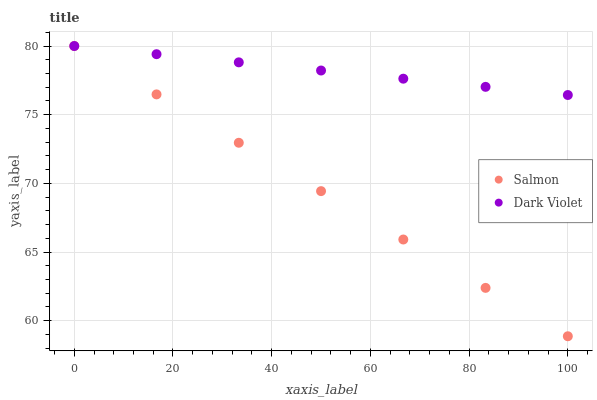Does Salmon have the minimum area under the curve?
Answer yes or no. Yes. Does Dark Violet have the maximum area under the curve?
Answer yes or no. Yes. Does Dark Violet have the minimum area under the curve?
Answer yes or no. No. Is Salmon the smoothest?
Answer yes or no. Yes. Is Dark Violet the roughest?
Answer yes or no. Yes. Is Dark Violet the smoothest?
Answer yes or no. No. Does Salmon have the lowest value?
Answer yes or no. Yes. Does Dark Violet have the lowest value?
Answer yes or no. No. Does Dark Violet have the highest value?
Answer yes or no. Yes. Does Dark Violet intersect Salmon?
Answer yes or no. Yes. Is Dark Violet less than Salmon?
Answer yes or no. No. Is Dark Violet greater than Salmon?
Answer yes or no. No. 